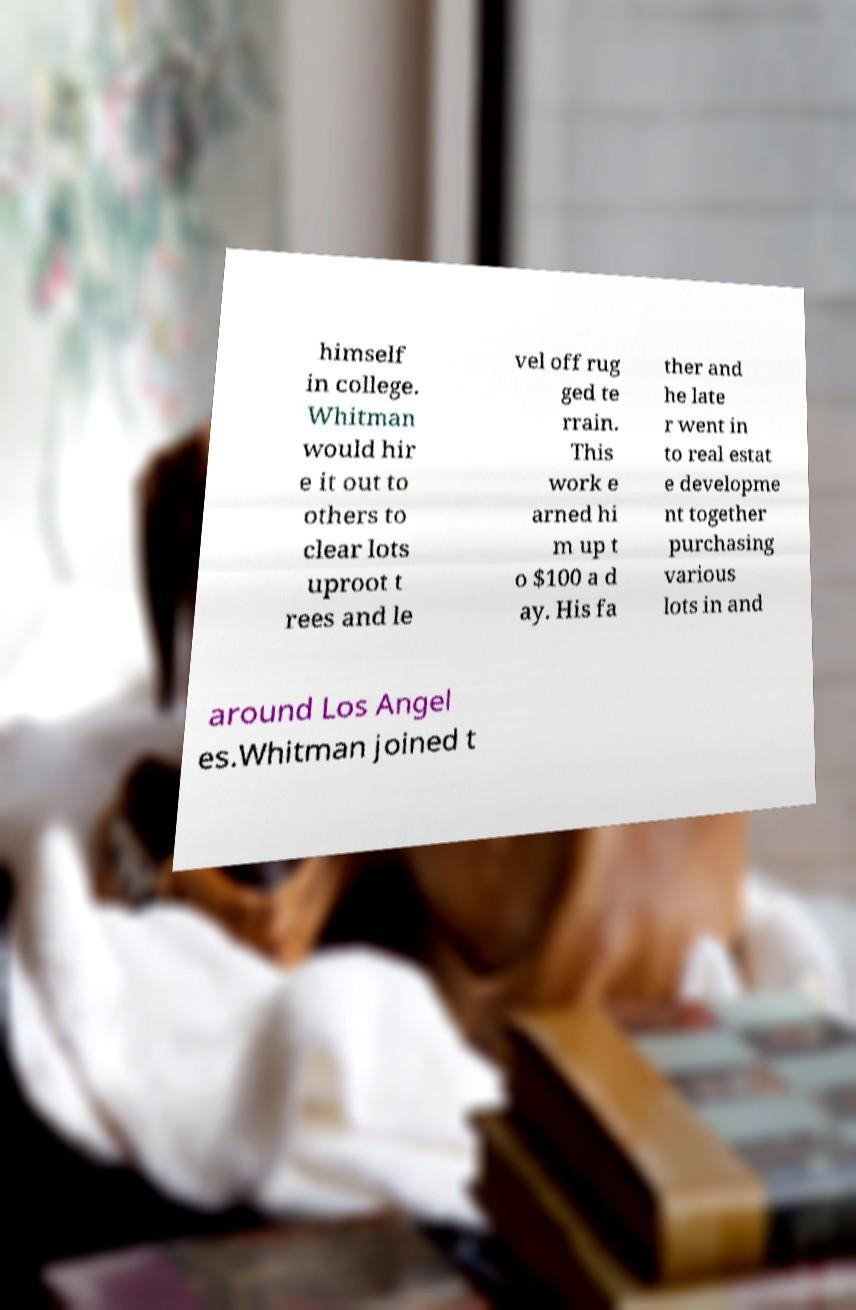There's text embedded in this image that I need extracted. Can you transcribe it verbatim? himself in college. Whitman would hir e it out to others to clear lots uproot t rees and le vel off rug ged te rrain. This work e arned hi m up t o $100 a d ay. His fa ther and he late r went in to real estat e developme nt together purchasing various lots in and around Los Angel es.Whitman joined t 